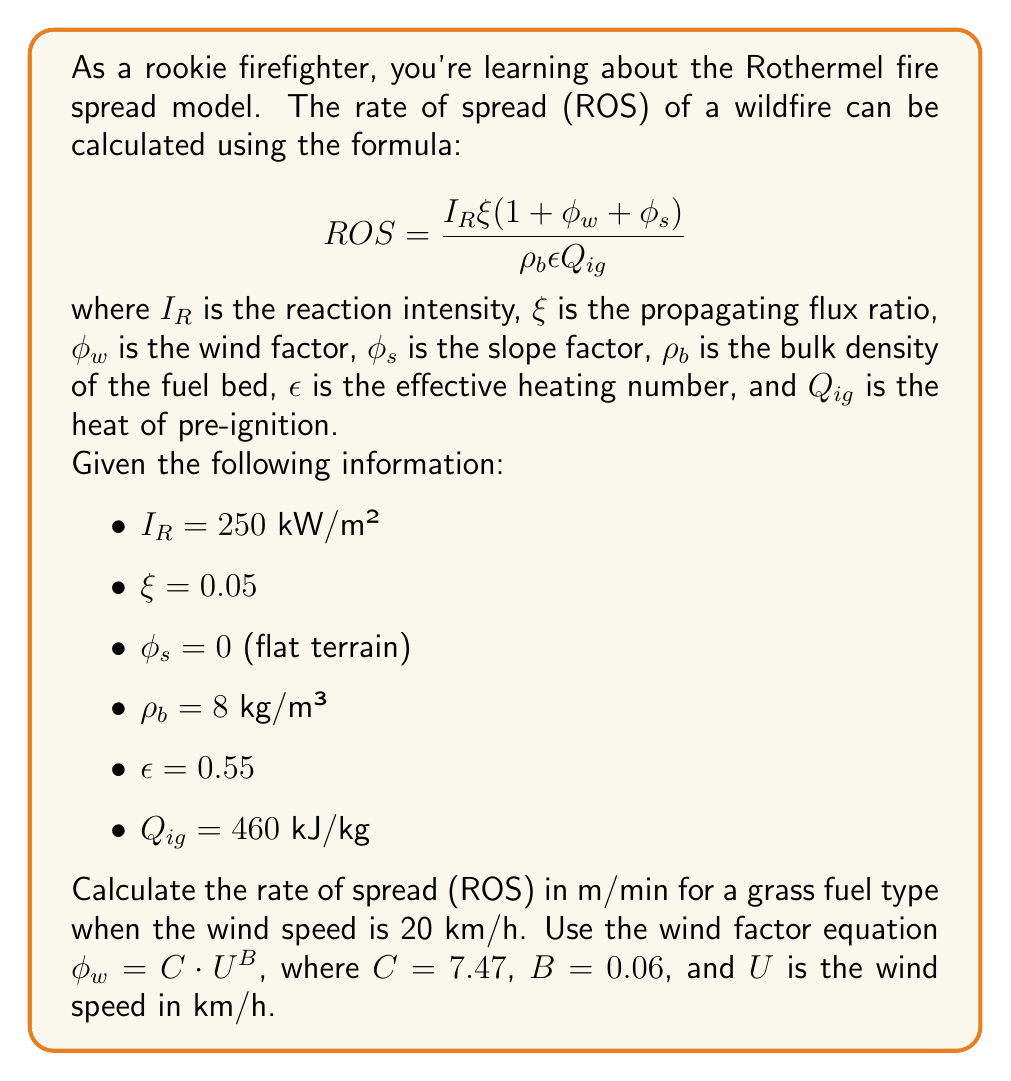Can you solve this math problem? To solve this problem, we'll follow these steps:

1. Calculate the wind factor $\phi_w$
2. Plug all values into the ROS equation
3. Simplify and solve for ROS

Step 1: Calculate the wind factor $\phi_w$

Given: $\phi_w = C \cdot U^B$, where $C = 7.47$, $B = 0.06$, and $U = 20$ km/h

$\phi_w = 7.47 \cdot 20^{0.06}$
$\phi_w = 7.47 \cdot 1.458$
$\phi_w = 10.89$

Step 2: Plug all values into the ROS equation

$$ ROS = \frac{I_R \xi (1 + \phi_w + \phi_s)}{\rho_b \epsilon Q_{ig}} $$

Substituting the given values:

$$ ROS = \frac{250 \cdot 0.05 \cdot (1 + 10.89 + 0)}{8 \cdot 0.55 \cdot 460} $$

Step 3: Simplify and solve for ROS

$$ ROS = \frac{250 \cdot 0.05 \cdot 11.89}{8 \cdot 0.55 \cdot 460} $$

$$ ROS = \frac{148.625}{2024} $$

$$ ROS = 0.0734 \text{ m/s} $$

Convert to m/min:
$$ ROS = 0.0734 \cdot 60 = 4.404 \text{ m/min} $$

Therefore, the rate of spread is approximately 4.40 m/min.
Answer: 4.40 m/min 